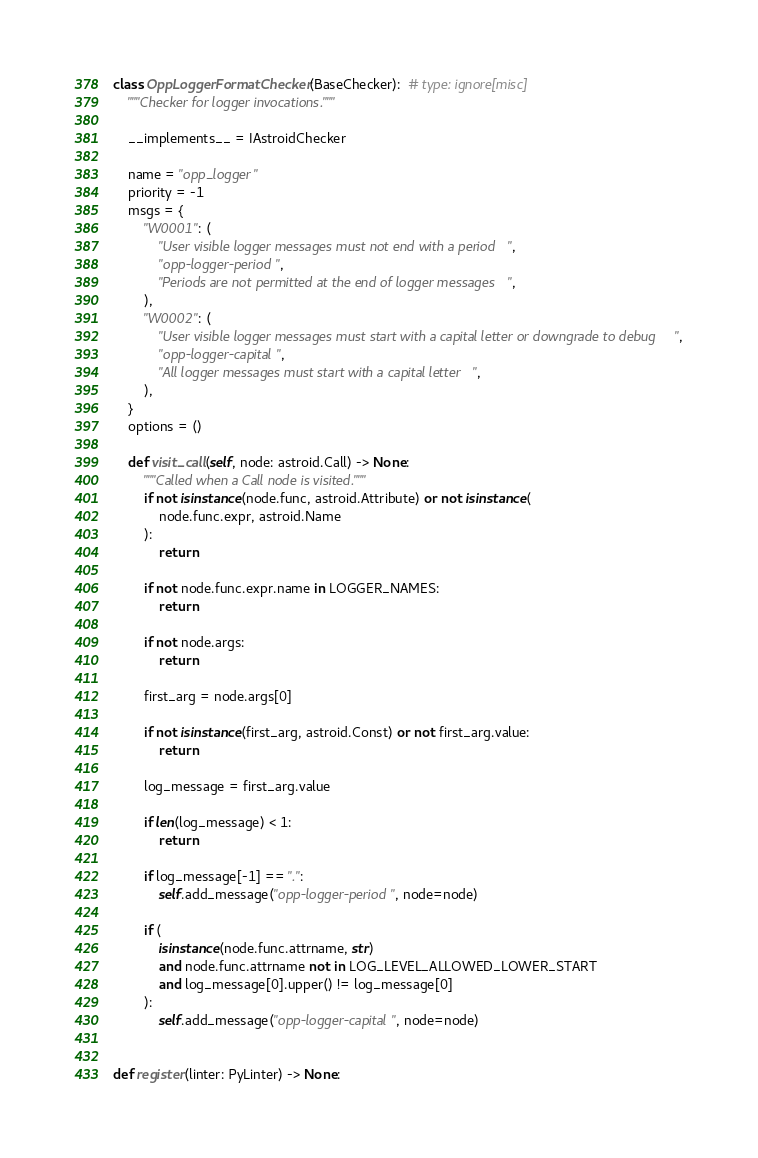Convert code to text. <code><loc_0><loc_0><loc_500><loc_500><_Python_>

class OppLoggerFormatChecker(BaseChecker):  # type: ignore[misc]
    """Checker for logger invocations."""

    __implements__ = IAstroidChecker

    name = "opp_logger"
    priority = -1
    msgs = {
        "W0001": (
            "User visible logger messages must not end with a period",
            "opp-logger-period",
            "Periods are not permitted at the end of logger messages",
        ),
        "W0002": (
            "User visible logger messages must start with a capital letter or downgrade to debug",
            "opp-logger-capital",
            "All logger messages must start with a capital letter",
        ),
    }
    options = ()

    def visit_call(self, node: astroid.Call) -> None:
        """Called when a Call node is visited."""
        if not isinstance(node.func, astroid.Attribute) or not isinstance(
            node.func.expr, astroid.Name
        ):
            return

        if not node.func.expr.name in LOGGER_NAMES:
            return

        if not node.args:
            return

        first_arg = node.args[0]

        if not isinstance(first_arg, astroid.Const) or not first_arg.value:
            return

        log_message = first_arg.value

        if len(log_message) < 1:
            return

        if log_message[-1] == ".":
            self.add_message("opp-logger-period", node=node)

        if (
            isinstance(node.func.attrname, str)
            and node.func.attrname not in LOG_LEVEL_ALLOWED_LOWER_START
            and log_message[0].upper() != log_message[0]
        ):
            self.add_message("opp-logger-capital", node=node)


def register(linter: PyLinter) -> None:</code> 